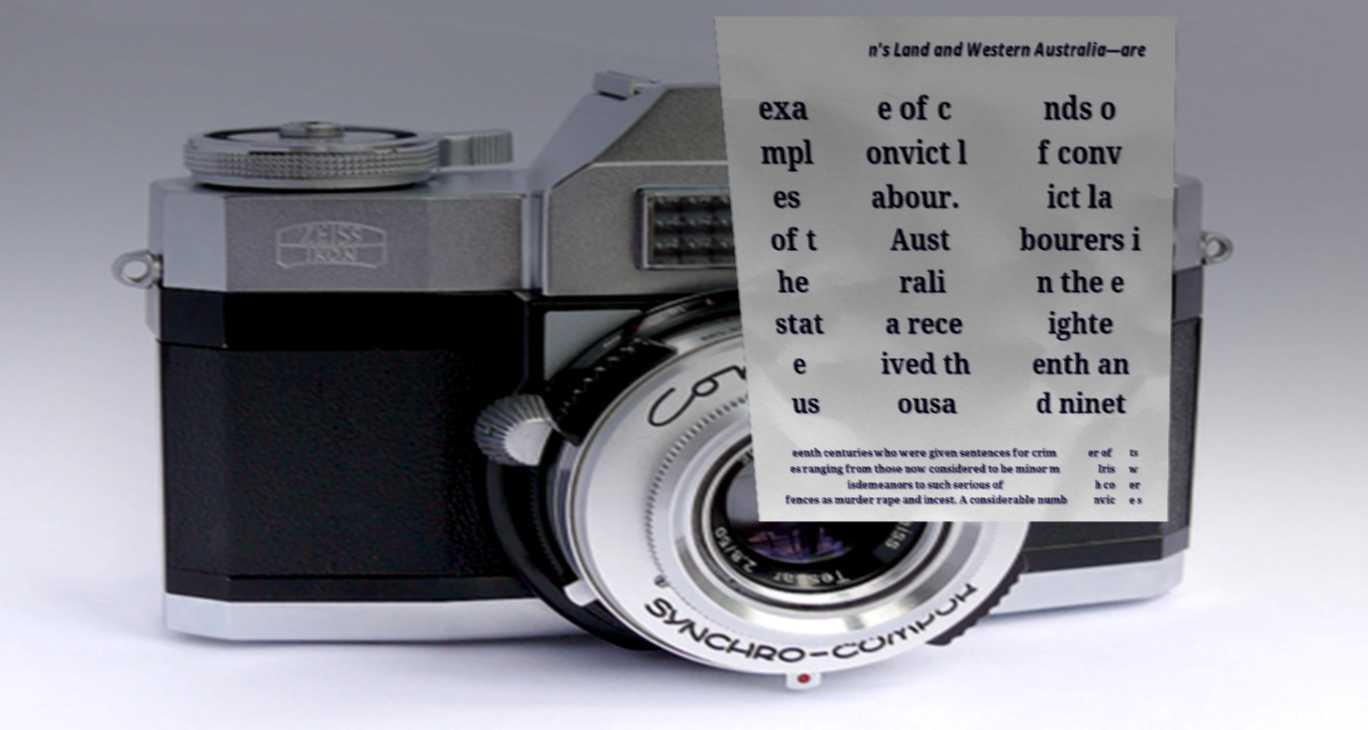I need the written content from this picture converted into text. Can you do that? n's Land and Western Australia—are exa mpl es of t he stat e us e of c onvict l abour. Aust rali a rece ived th ousa nds o f conv ict la bourers i n the e ighte enth an d ninet eenth centuries who were given sentences for crim es ranging from those now considered to be minor m isdemeanors to such serious of fences as murder rape and incest. A considerable numb er of Iris h co nvic ts w er e s 